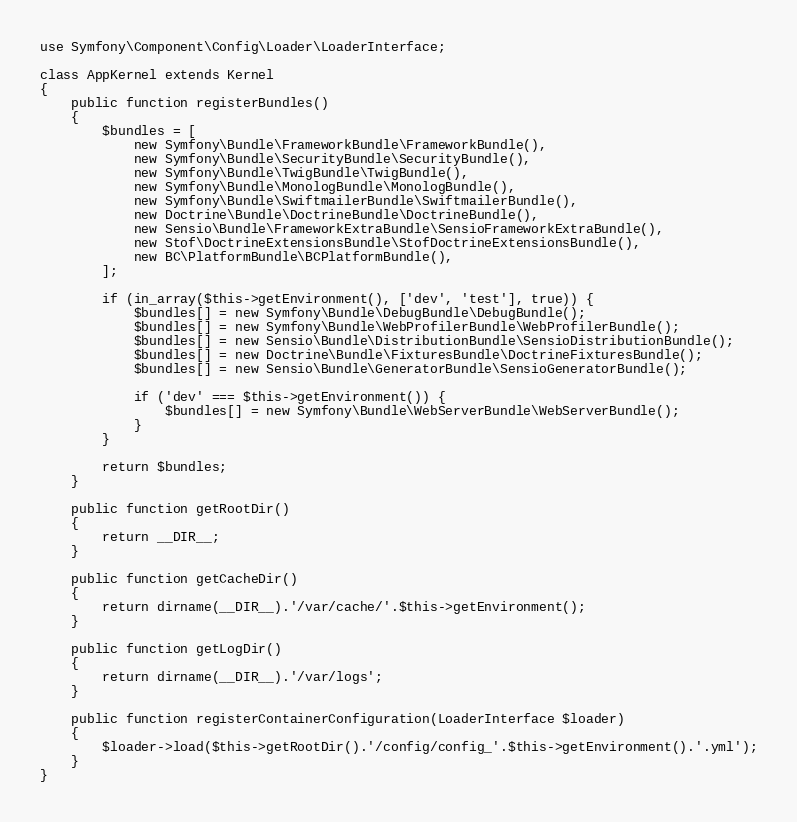Convert code to text. <code><loc_0><loc_0><loc_500><loc_500><_PHP_>use Symfony\Component\Config\Loader\LoaderInterface;

class AppKernel extends Kernel
{
    public function registerBundles()
    {
        $bundles = [
            new Symfony\Bundle\FrameworkBundle\FrameworkBundle(),
            new Symfony\Bundle\SecurityBundle\SecurityBundle(),
            new Symfony\Bundle\TwigBundle\TwigBundle(),
            new Symfony\Bundle\MonologBundle\MonologBundle(),
            new Symfony\Bundle\SwiftmailerBundle\SwiftmailerBundle(),
            new Doctrine\Bundle\DoctrineBundle\DoctrineBundle(),
            new Sensio\Bundle\FrameworkExtraBundle\SensioFrameworkExtraBundle(),
            new Stof\DoctrineExtensionsBundle\StofDoctrineExtensionsBundle(),
            new BC\PlatformBundle\BCPlatformBundle(),
        ];

        if (in_array($this->getEnvironment(), ['dev', 'test'], true)) {
            $bundles[] = new Symfony\Bundle\DebugBundle\DebugBundle();
            $bundles[] = new Symfony\Bundle\WebProfilerBundle\WebProfilerBundle();
            $bundles[] = new Sensio\Bundle\DistributionBundle\SensioDistributionBundle();
            $bundles[] = new Doctrine\Bundle\FixturesBundle\DoctrineFixturesBundle();
            $bundles[] = new Sensio\Bundle\GeneratorBundle\SensioGeneratorBundle();

            if ('dev' === $this->getEnvironment()) {
                $bundles[] = new Symfony\Bundle\WebServerBundle\WebServerBundle();
            }
        }

        return $bundles;
    }

    public function getRootDir()
    {
        return __DIR__;
    }

    public function getCacheDir()
    {
        return dirname(__DIR__).'/var/cache/'.$this->getEnvironment();
    }

    public function getLogDir()
    {
        return dirname(__DIR__).'/var/logs';
    }

    public function registerContainerConfiguration(LoaderInterface $loader)
    {
        $loader->load($this->getRootDir().'/config/config_'.$this->getEnvironment().'.yml');
    }
}
</code> 